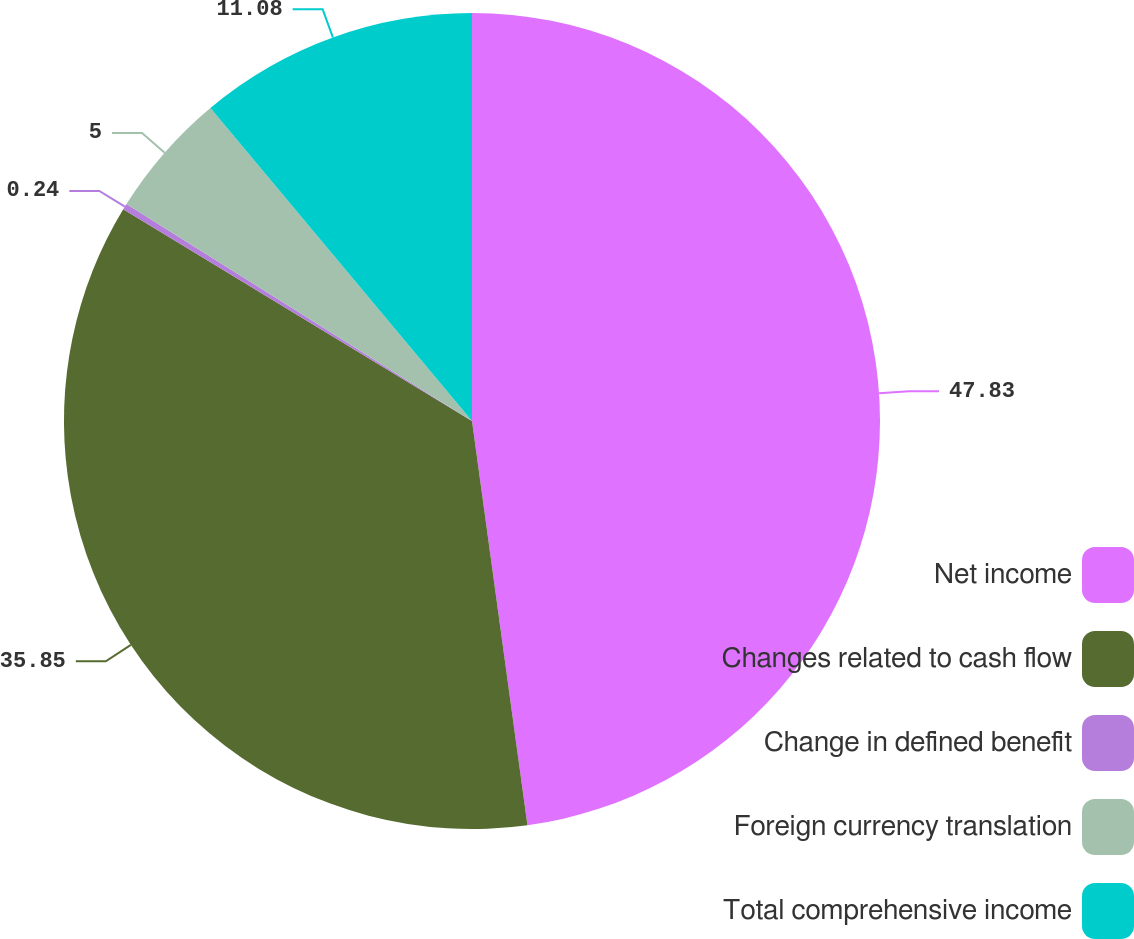Convert chart to OTSL. <chart><loc_0><loc_0><loc_500><loc_500><pie_chart><fcel>Net income<fcel>Changes related to cash flow<fcel>Change in defined benefit<fcel>Foreign currency translation<fcel>Total comprehensive income<nl><fcel>47.84%<fcel>35.86%<fcel>0.24%<fcel>5.0%<fcel>11.08%<nl></chart> 